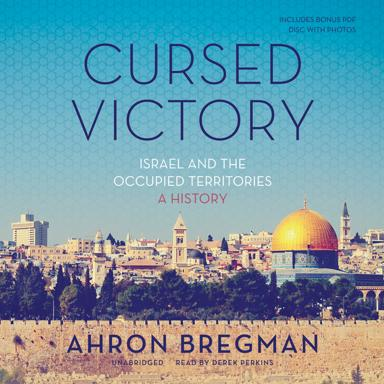What historical events might the book discuss, based on the title and cover image? Based on the title and cover image, the book likely discusses key events related to Israel and the occupied territories, such as the wars of 1967 and 1973, the peace processes, and ongoing tensions. It might also delve into the daily lives and struggles of people living in these areas, exploring themes of conflict, sovereignty, and the quest for peace. How does the content of the photos on the bonus disc complement the book's narrative? The photos on the bonus disc likely provide a visual representation of key places and moments discussed in the book. They serve as a powerful tool for readers to connect more deeply with the historical events, by seeing images of the people, landscapes, and landmarks that have shaped the history of Israel and the occupied territories. 